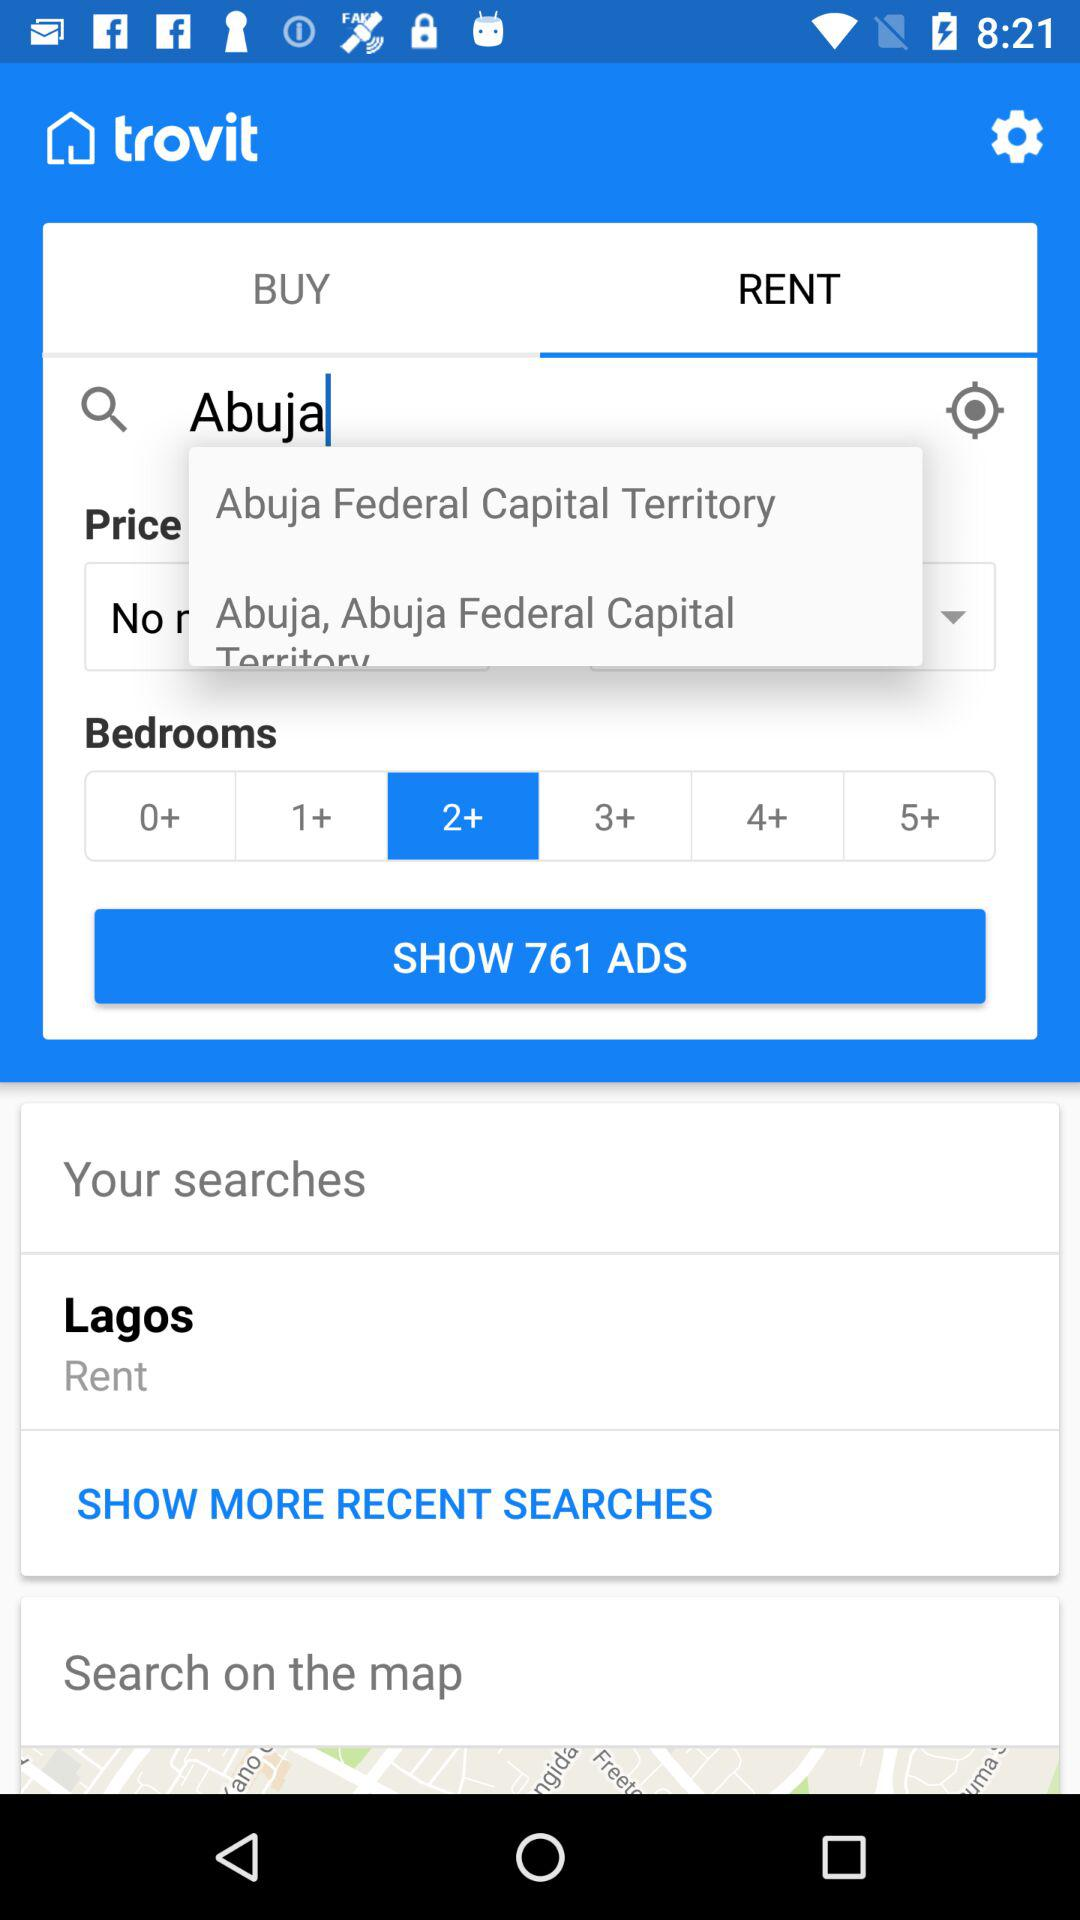Which tab is selected? The selected tab is "RENT". 